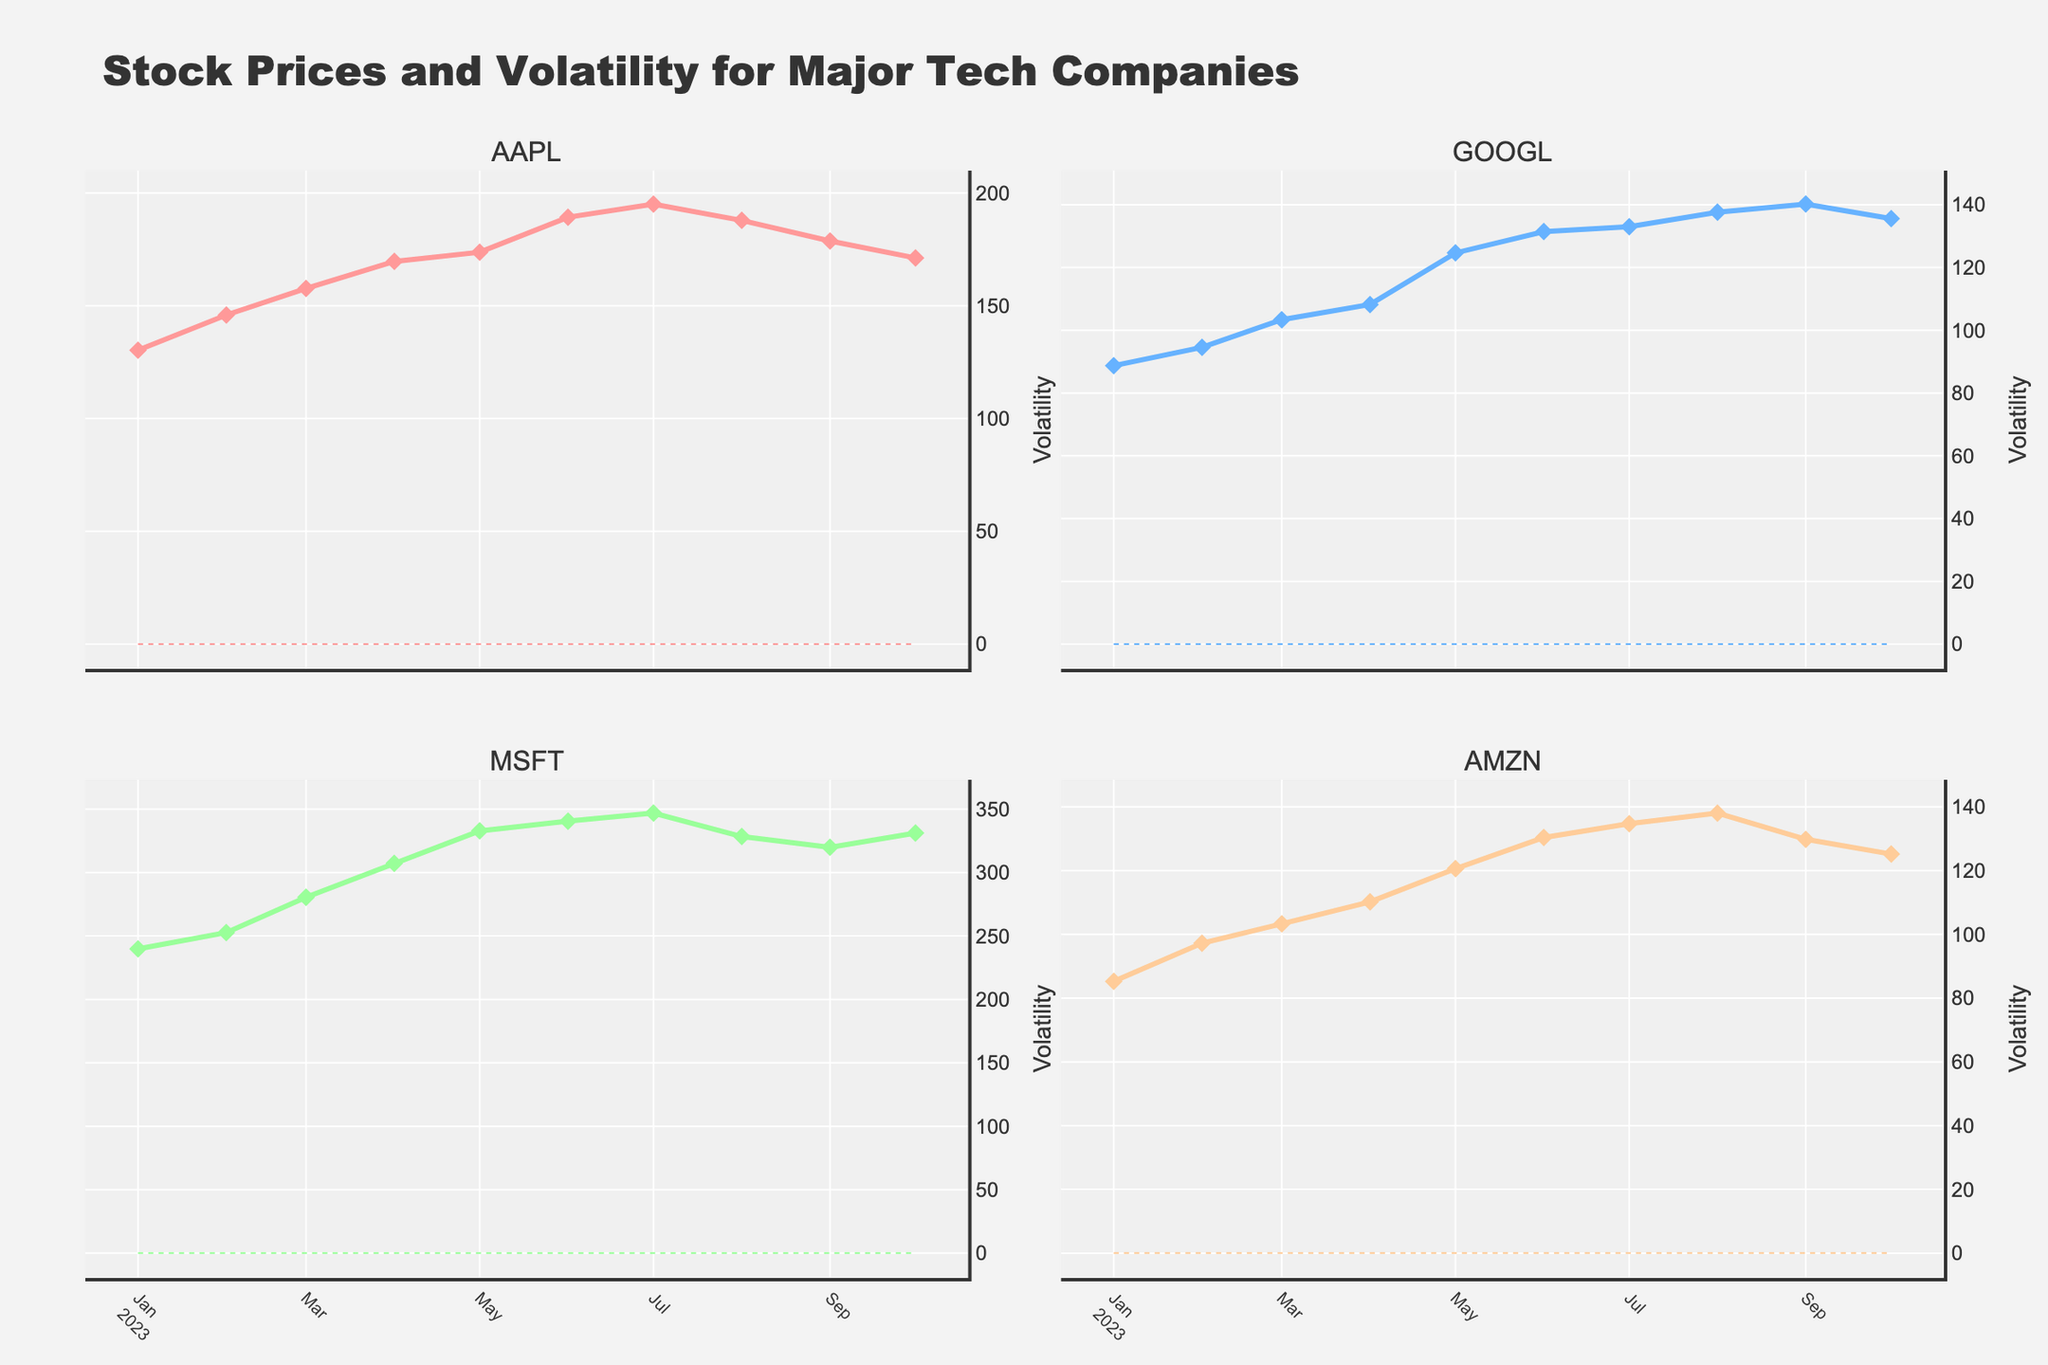What is the title of the figure? The title of a figure is usually prominently displayed at the top. In this figure, the title is "Stock Prices and Volatility for Major Tech Companies".
Answer: Stock Prices and Volatility for Major Tech Companies How many tech companies are compared in the figure? The figure comprises four subplots, each titled with a different company name: AAPL, GOOGL, MSFT, and AMZN. This indicates that four tech companies are being compared.
Answer: four What is the date range of the data shown in the figure? By observing the x-axis of any graph, we can see that the time series starts from January 2023 and ends in October 2023.
Answer: January 2023 to October 2023 Which company had the highest stock price in July 2023? By checking the subplot titled "MSFT" and observing the data point on the line corresponding with July 2023, MSFT has the highest price around 346.87.
Answer: MSFT What is the average volatility of AAPL over the observed period? Add the volatility values of AAPL from each data point (0.0214 + 0.0187 + 0.0225 + 0.0198 + 0.0236 + 0.0209 + 0.0243 + 0.0221 + 0.0256 + 0.0234) and then divide by 10.
Answer: 0.02223 Which company shows the greatest increase in stock price from January to October 2023? Comparing the stock prices in January and October for each company, we have:
AAPL: 171.21 - 130.28, GOOGL: 135.60 - 88.73, MSFT: 331.16 - 239.82, AMZN: 125.17 - 85.25. Calculate the difference for each and identify that GOOGL has the greatest increase.
Answer: GOOGL Does any company's volatility always stay below 0.02 during the observed period? By checking the volatility y-axis on the subplots, MSFT is the only company with all volatility values under 0.02 across all months.
Answer: No Which company had the most volatile month, and when was it? By observing the maximum volatility spike in any subplot, we see that AMZN's highest volatility is in September 2023 with a value of 0.0271.
Answer: AMZN in September 2023 What is the relationship between the volatility and stock prices for AAPL in July 2023? Observing the AAPL subplot, in July 2023 when volatility rises to 0.0243, its stock price also hits one of its highest values at 195.10.
Answer: Both increased How does the stock price trend of GOOGL compare to AMZN? Overall, both companies show upward trends, but GOOGL has a steadier and more pronounced increase compared to AMZN’s more varied increments.
Answer: GOOGL shows a steadier increase compared to AMZN 